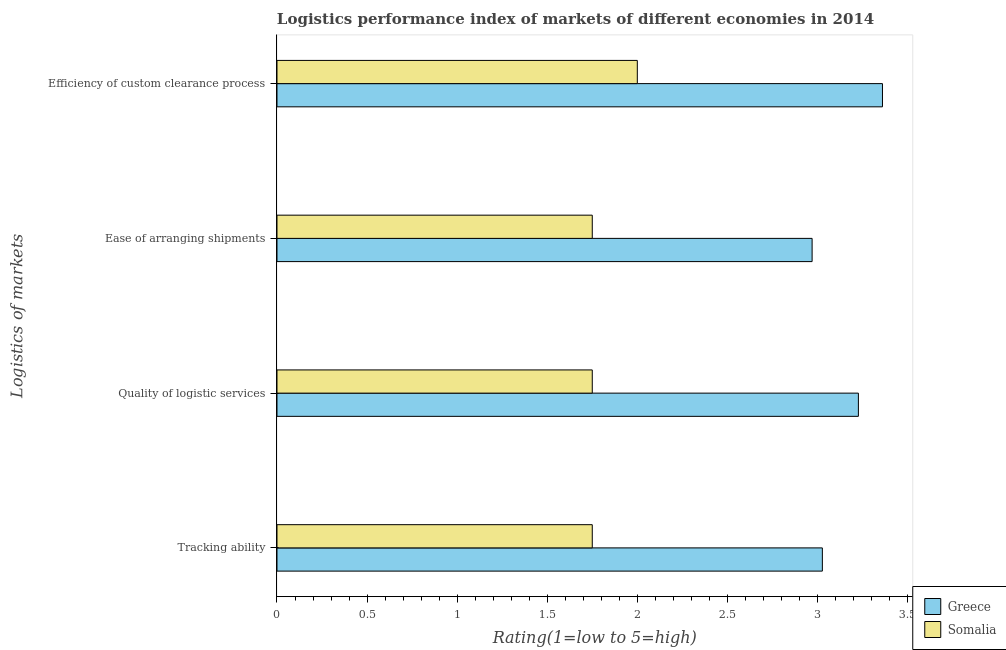How many groups of bars are there?
Provide a succinct answer. 4. What is the label of the 4th group of bars from the top?
Make the answer very short. Tracking ability. What is the lpi rating of ease of arranging shipments in Greece?
Offer a terse response. 2.97. Across all countries, what is the maximum lpi rating of quality of logistic services?
Your answer should be compact. 3.23. Across all countries, what is the minimum lpi rating of efficiency of custom clearance process?
Provide a succinct answer. 2. In which country was the lpi rating of tracking ability minimum?
Provide a succinct answer. Somalia. What is the total lpi rating of quality of logistic services in the graph?
Your answer should be very brief. 4.98. What is the difference between the lpi rating of efficiency of custom clearance process in Somalia and that in Greece?
Make the answer very short. -1.36. What is the difference between the lpi rating of ease of arranging shipments in Somalia and the lpi rating of quality of logistic services in Greece?
Ensure brevity in your answer.  -1.48. What is the average lpi rating of quality of logistic services per country?
Provide a short and direct response. 2.49. In how many countries, is the lpi rating of ease of arranging shipments greater than 2 ?
Offer a terse response. 1. What is the ratio of the lpi rating of quality of logistic services in Greece to that in Somalia?
Offer a very short reply. 1.84. Is the lpi rating of ease of arranging shipments in Greece less than that in Somalia?
Ensure brevity in your answer.  No. What is the difference between the highest and the second highest lpi rating of efficiency of custom clearance process?
Your answer should be very brief. 1.36. What is the difference between the highest and the lowest lpi rating of ease of arranging shipments?
Give a very brief answer. 1.22. In how many countries, is the lpi rating of ease of arranging shipments greater than the average lpi rating of ease of arranging shipments taken over all countries?
Give a very brief answer. 1. Is the sum of the lpi rating of efficiency of custom clearance process in Greece and Somalia greater than the maximum lpi rating of tracking ability across all countries?
Make the answer very short. Yes. What does the 2nd bar from the top in Efficiency of custom clearance process represents?
Your answer should be very brief. Greece. What does the 2nd bar from the bottom in Ease of arranging shipments represents?
Give a very brief answer. Somalia. How many bars are there?
Your answer should be compact. 8. Are all the bars in the graph horizontal?
Your response must be concise. Yes. How many countries are there in the graph?
Your response must be concise. 2. What is the title of the graph?
Your answer should be compact. Logistics performance index of markets of different economies in 2014. Does "Brazil" appear as one of the legend labels in the graph?
Give a very brief answer. No. What is the label or title of the X-axis?
Provide a short and direct response. Rating(1=low to 5=high). What is the label or title of the Y-axis?
Give a very brief answer. Logistics of markets. What is the Rating(1=low to 5=high) of Greece in Tracking ability?
Give a very brief answer. 3.03. What is the Rating(1=low to 5=high) of Somalia in Tracking ability?
Provide a succinct answer. 1.75. What is the Rating(1=low to 5=high) of Greece in Quality of logistic services?
Your answer should be compact. 3.23. What is the Rating(1=low to 5=high) in Somalia in Quality of logistic services?
Provide a succinct answer. 1.75. What is the Rating(1=low to 5=high) in Greece in Ease of arranging shipments?
Offer a terse response. 2.97. What is the Rating(1=low to 5=high) of Somalia in Ease of arranging shipments?
Keep it short and to the point. 1.75. What is the Rating(1=low to 5=high) in Greece in Efficiency of custom clearance process?
Give a very brief answer. 3.36. Across all Logistics of markets, what is the maximum Rating(1=low to 5=high) of Greece?
Provide a succinct answer. 3.36. Across all Logistics of markets, what is the maximum Rating(1=low to 5=high) of Somalia?
Keep it short and to the point. 2. Across all Logistics of markets, what is the minimum Rating(1=low to 5=high) in Greece?
Your answer should be very brief. 2.97. Across all Logistics of markets, what is the minimum Rating(1=low to 5=high) of Somalia?
Offer a terse response. 1.75. What is the total Rating(1=low to 5=high) in Greece in the graph?
Your response must be concise. 12.59. What is the total Rating(1=low to 5=high) in Somalia in the graph?
Give a very brief answer. 7.25. What is the difference between the Rating(1=low to 5=high) in Somalia in Tracking ability and that in Quality of logistic services?
Keep it short and to the point. 0. What is the difference between the Rating(1=low to 5=high) in Greece in Tracking ability and that in Ease of arranging shipments?
Offer a very short reply. 0.06. What is the difference between the Rating(1=low to 5=high) of Greece in Tracking ability and that in Efficiency of custom clearance process?
Provide a short and direct response. -0.33. What is the difference between the Rating(1=low to 5=high) of Somalia in Tracking ability and that in Efficiency of custom clearance process?
Your answer should be compact. -0.25. What is the difference between the Rating(1=low to 5=high) in Greece in Quality of logistic services and that in Ease of arranging shipments?
Provide a short and direct response. 0.26. What is the difference between the Rating(1=low to 5=high) in Somalia in Quality of logistic services and that in Ease of arranging shipments?
Make the answer very short. 0. What is the difference between the Rating(1=low to 5=high) in Greece in Quality of logistic services and that in Efficiency of custom clearance process?
Your answer should be compact. -0.13. What is the difference between the Rating(1=low to 5=high) in Greece in Ease of arranging shipments and that in Efficiency of custom clearance process?
Offer a very short reply. -0.39. What is the difference between the Rating(1=low to 5=high) of Greece in Tracking ability and the Rating(1=low to 5=high) of Somalia in Quality of logistic services?
Keep it short and to the point. 1.28. What is the difference between the Rating(1=low to 5=high) of Greece in Tracking ability and the Rating(1=low to 5=high) of Somalia in Ease of arranging shipments?
Your answer should be very brief. 1.28. What is the difference between the Rating(1=low to 5=high) in Greece in Tracking ability and the Rating(1=low to 5=high) in Somalia in Efficiency of custom clearance process?
Provide a succinct answer. 1.03. What is the difference between the Rating(1=low to 5=high) in Greece in Quality of logistic services and the Rating(1=low to 5=high) in Somalia in Ease of arranging shipments?
Ensure brevity in your answer.  1.48. What is the difference between the Rating(1=low to 5=high) of Greece in Quality of logistic services and the Rating(1=low to 5=high) of Somalia in Efficiency of custom clearance process?
Your answer should be compact. 1.23. What is the difference between the Rating(1=low to 5=high) of Greece in Ease of arranging shipments and the Rating(1=low to 5=high) of Somalia in Efficiency of custom clearance process?
Your response must be concise. 0.97. What is the average Rating(1=low to 5=high) in Greece per Logistics of markets?
Ensure brevity in your answer.  3.15. What is the average Rating(1=low to 5=high) of Somalia per Logistics of markets?
Provide a short and direct response. 1.81. What is the difference between the Rating(1=low to 5=high) of Greece and Rating(1=low to 5=high) of Somalia in Tracking ability?
Provide a short and direct response. 1.28. What is the difference between the Rating(1=low to 5=high) of Greece and Rating(1=low to 5=high) of Somalia in Quality of logistic services?
Your answer should be very brief. 1.48. What is the difference between the Rating(1=low to 5=high) of Greece and Rating(1=low to 5=high) of Somalia in Ease of arranging shipments?
Keep it short and to the point. 1.22. What is the difference between the Rating(1=low to 5=high) of Greece and Rating(1=low to 5=high) of Somalia in Efficiency of custom clearance process?
Ensure brevity in your answer.  1.36. What is the ratio of the Rating(1=low to 5=high) of Greece in Tracking ability to that in Quality of logistic services?
Your answer should be compact. 0.94. What is the ratio of the Rating(1=low to 5=high) of Greece in Tracking ability to that in Ease of arranging shipments?
Give a very brief answer. 1.02. What is the ratio of the Rating(1=low to 5=high) in Somalia in Tracking ability to that in Ease of arranging shipments?
Your answer should be compact. 1. What is the ratio of the Rating(1=low to 5=high) of Greece in Tracking ability to that in Efficiency of custom clearance process?
Your answer should be compact. 0.9. What is the ratio of the Rating(1=low to 5=high) in Greece in Quality of logistic services to that in Ease of arranging shipments?
Your response must be concise. 1.09. What is the ratio of the Rating(1=low to 5=high) in Greece in Quality of logistic services to that in Efficiency of custom clearance process?
Offer a terse response. 0.96. What is the ratio of the Rating(1=low to 5=high) in Somalia in Quality of logistic services to that in Efficiency of custom clearance process?
Your response must be concise. 0.88. What is the ratio of the Rating(1=low to 5=high) in Greece in Ease of arranging shipments to that in Efficiency of custom clearance process?
Provide a succinct answer. 0.88. What is the difference between the highest and the second highest Rating(1=low to 5=high) in Greece?
Offer a terse response. 0.13. What is the difference between the highest and the second highest Rating(1=low to 5=high) of Somalia?
Offer a very short reply. 0.25. What is the difference between the highest and the lowest Rating(1=low to 5=high) in Greece?
Keep it short and to the point. 0.39. What is the difference between the highest and the lowest Rating(1=low to 5=high) in Somalia?
Offer a terse response. 0.25. 